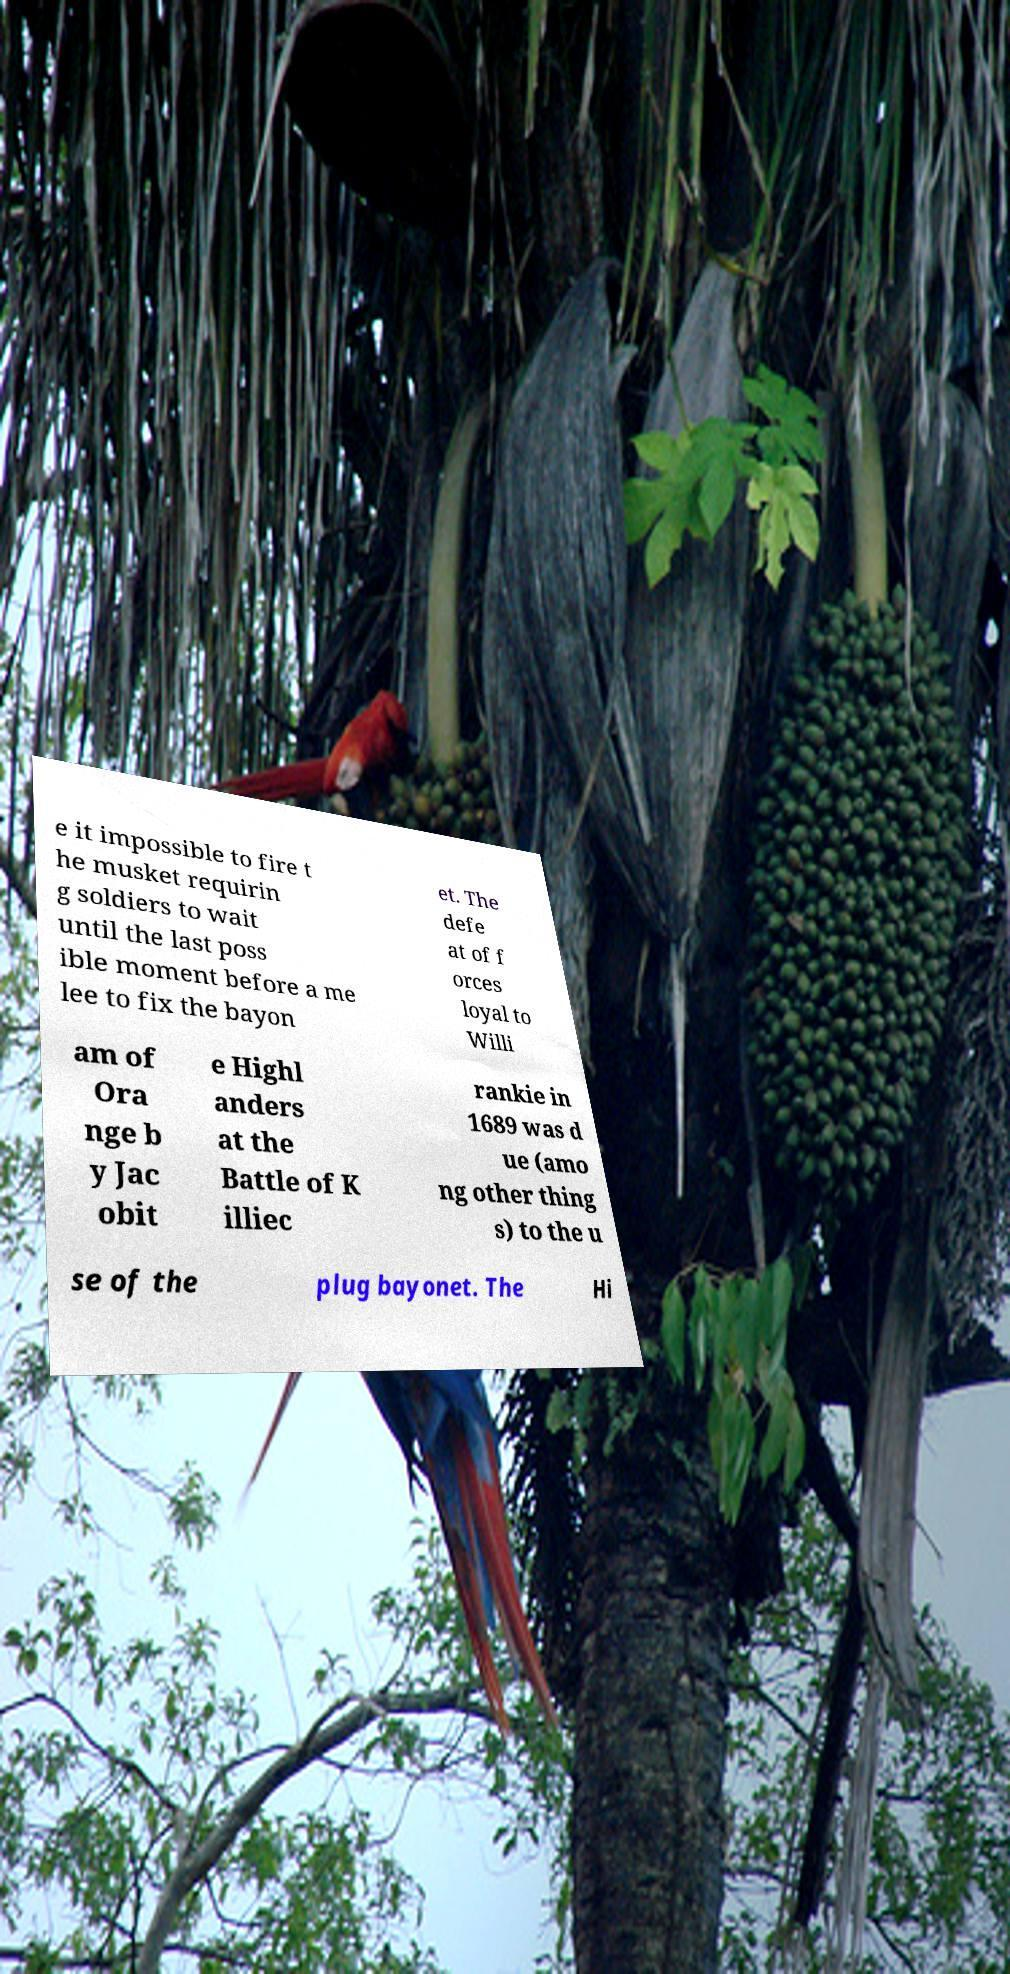Can you read and provide the text displayed in the image?This photo seems to have some interesting text. Can you extract and type it out for me? e it impossible to fire t he musket requirin g soldiers to wait until the last poss ible moment before a me lee to fix the bayon et. The defe at of f orces loyal to Willi am of Ora nge b y Jac obit e Highl anders at the Battle of K illiec rankie in 1689 was d ue (amo ng other thing s) to the u se of the plug bayonet. The Hi 